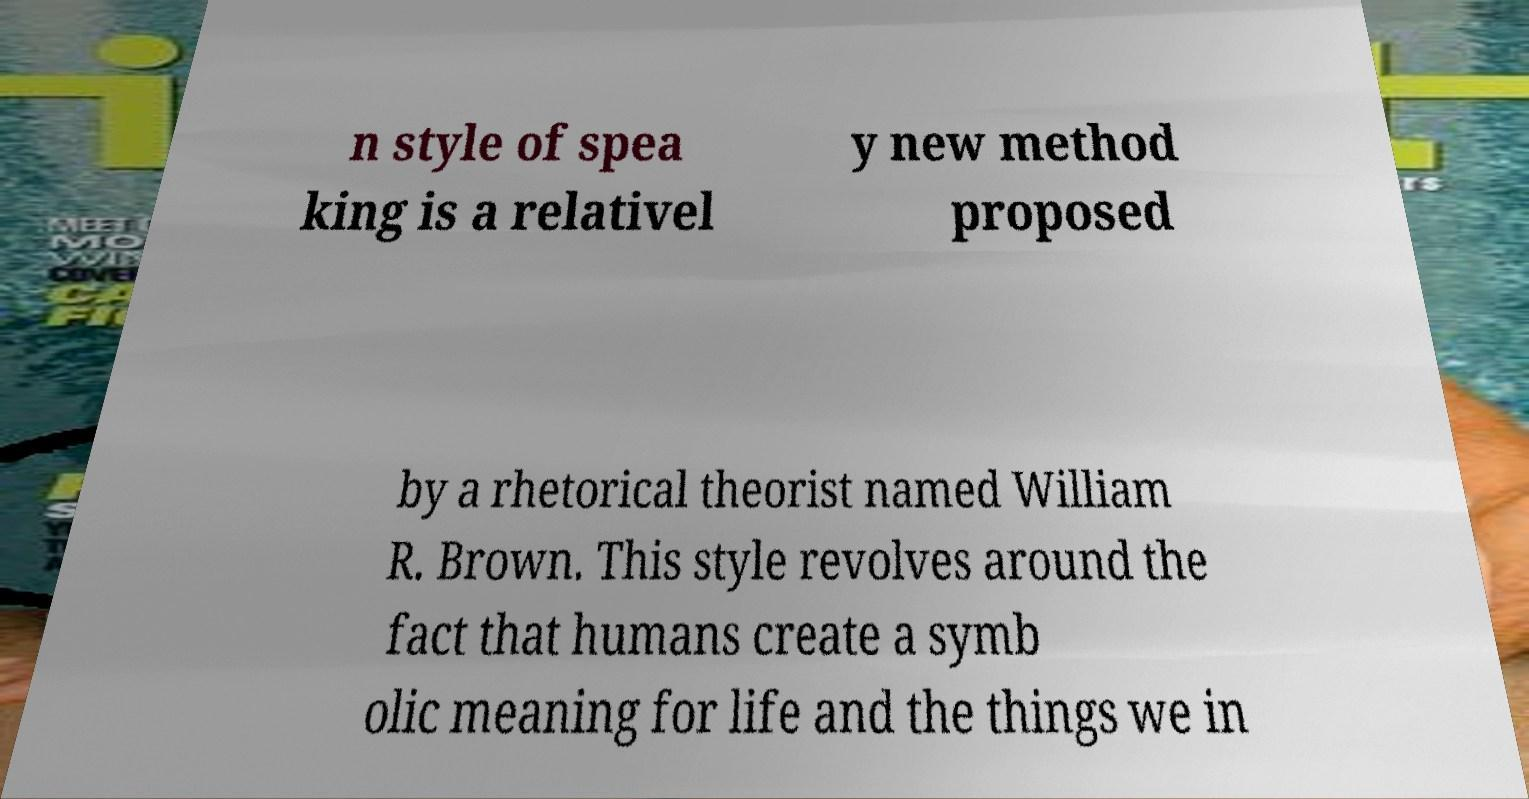I need the written content from this picture converted into text. Can you do that? n style of spea king is a relativel y new method proposed by a rhetorical theorist named William R. Brown. This style revolves around the fact that humans create a symb olic meaning for life and the things we in 